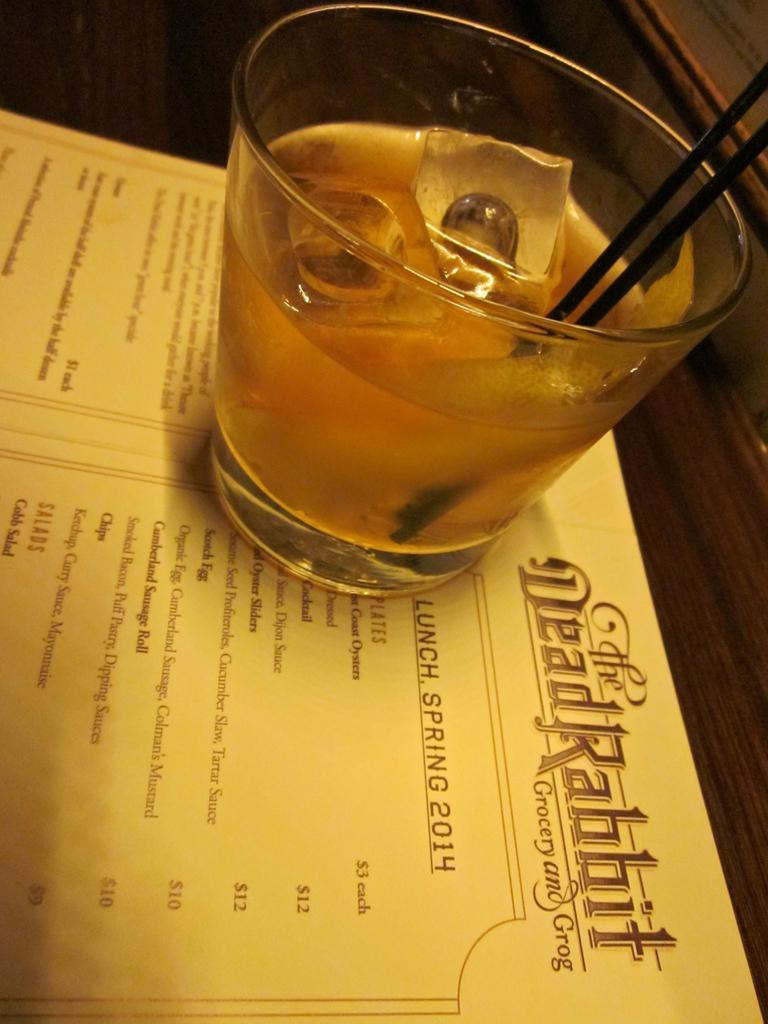<image>
Share a concise interpretation of the image provided. A drink in a small glass sitting atop a restaurant menu by the name of The DeadRabbit Grocery and Grog. 